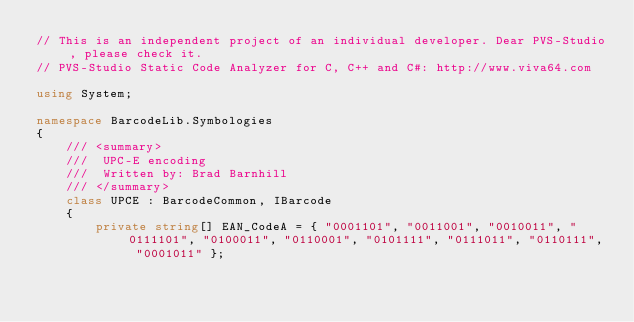<code> <loc_0><loc_0><loc_500><loc_500><_C#_>// This is an independent project of an individual developer. Dear PVS-Studio, please check it.
// PVS-Studio Static Code Analyzer for C, C++ and C#: http://www.viva64.com

using System;

namespace BarcodeLib.Symbologies
{
    /// <summary>
    ///  UPC-E encoding
    ///  Written by: Brad Barnhill
    /// </summary>
    class UPCE : BarcodeCommon, IBarcode
    {
        private string[] EAN_CodeA = { "0001101", "0011001", "0010011", "0111101", "0100011", "0110001", "0101111", "0111011", "0110111", "0001011" };</code> 